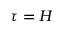Convert formula to latex. <formula><loc_0><loc_0><loc_500><loc_500>\tau = H</formula> 